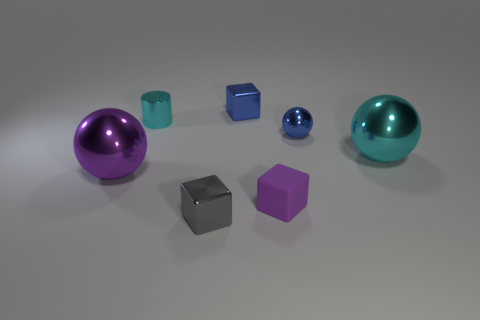Add 2 small blue matte cubes. How many objects exist? 9 Subtract all spheres. How many objects are left? 4 Add 3 small objects. How many small objects exist? 8 Subtract 0 gray spheres. How many objects are left? 7 Subtract all large purple shiny cylinders. Subtract all tiny metallic things. How many objects are left? 3 Add 4 small purple things. How many small purple things are left? 5 